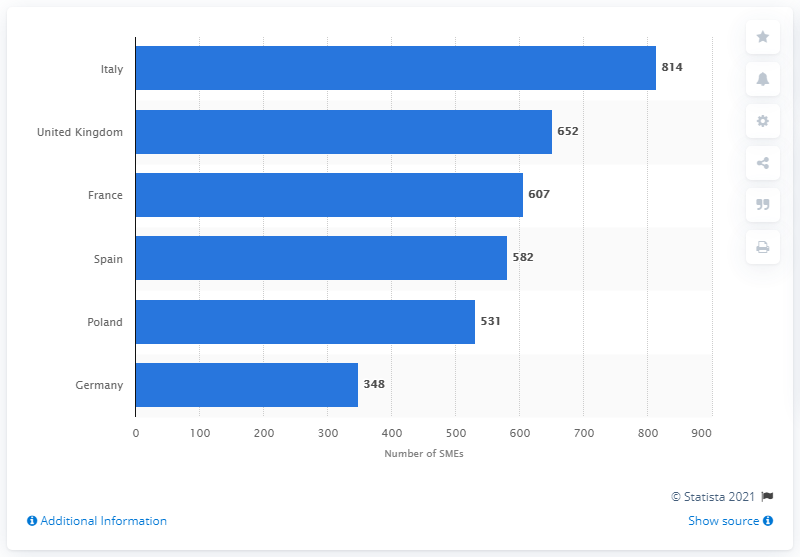List a handful of essential elements in this visual. In 2019, there were 607 cosmetic manufacturing small and medium enterprises in France. In 2019, there were 814 small and medium-sized enterprises in the cosmetics manufacturing industry in Italy. In 2019, there were 652 small and medium enterprises in the cosmetics manufacturing industry in the United Kingdom. 